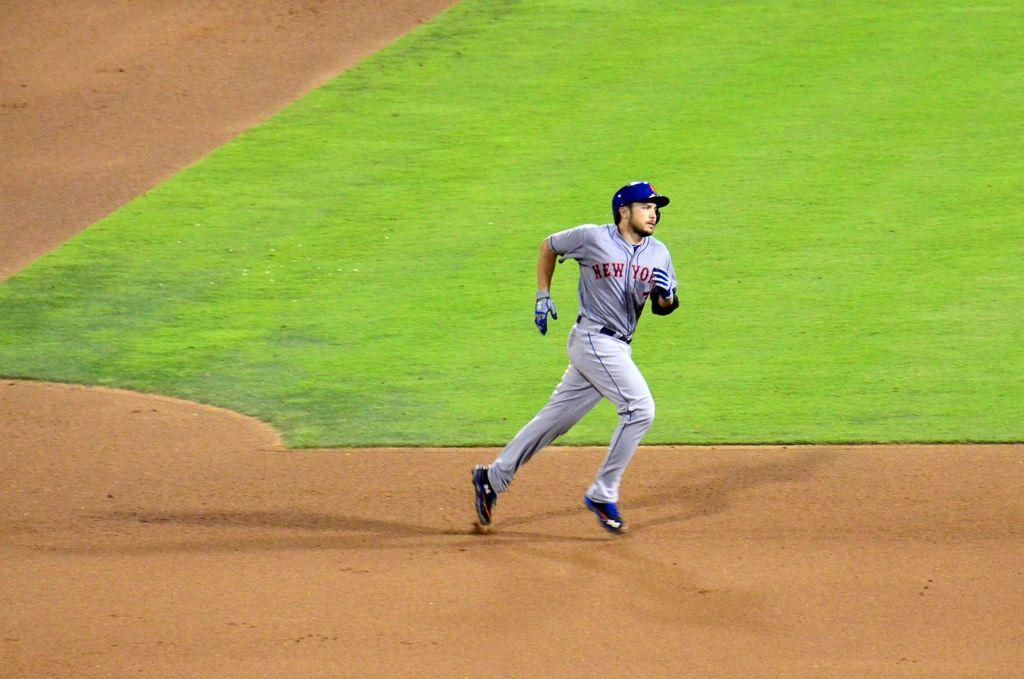<image>
Give a short and clear explanation of the subsequent image. new york baseball player running to a base 